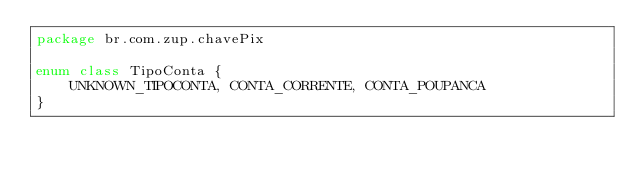<code> <loc_0><loc_0><loc_500><loc_500><_Kotlin_>package br.com.zup.chavePix

enum class TipoConta {
    UNKNOWN_TIPOCONTA, CONTA_CORRENTE, CONTA_POUPANCA
}</code> 